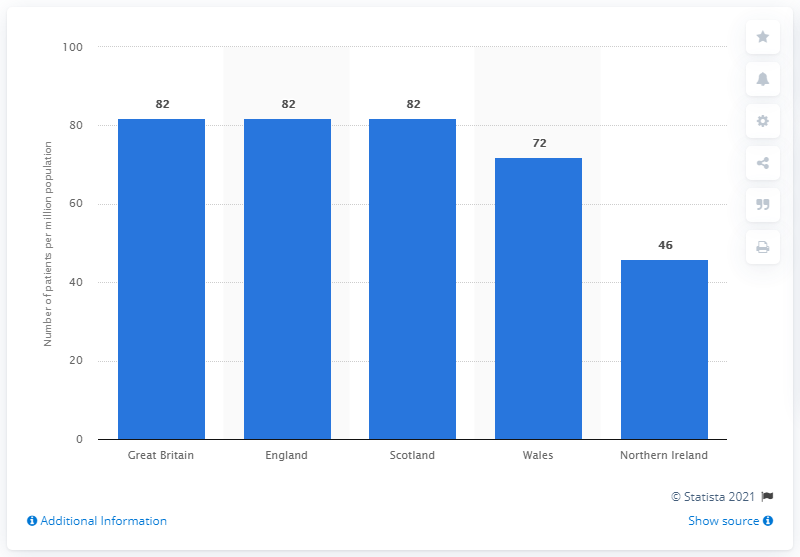Identify some key points in this picture. According to data from Great Britain in 2015, the average rate of patients with all-cause pulmonary hypertension was 82%. 